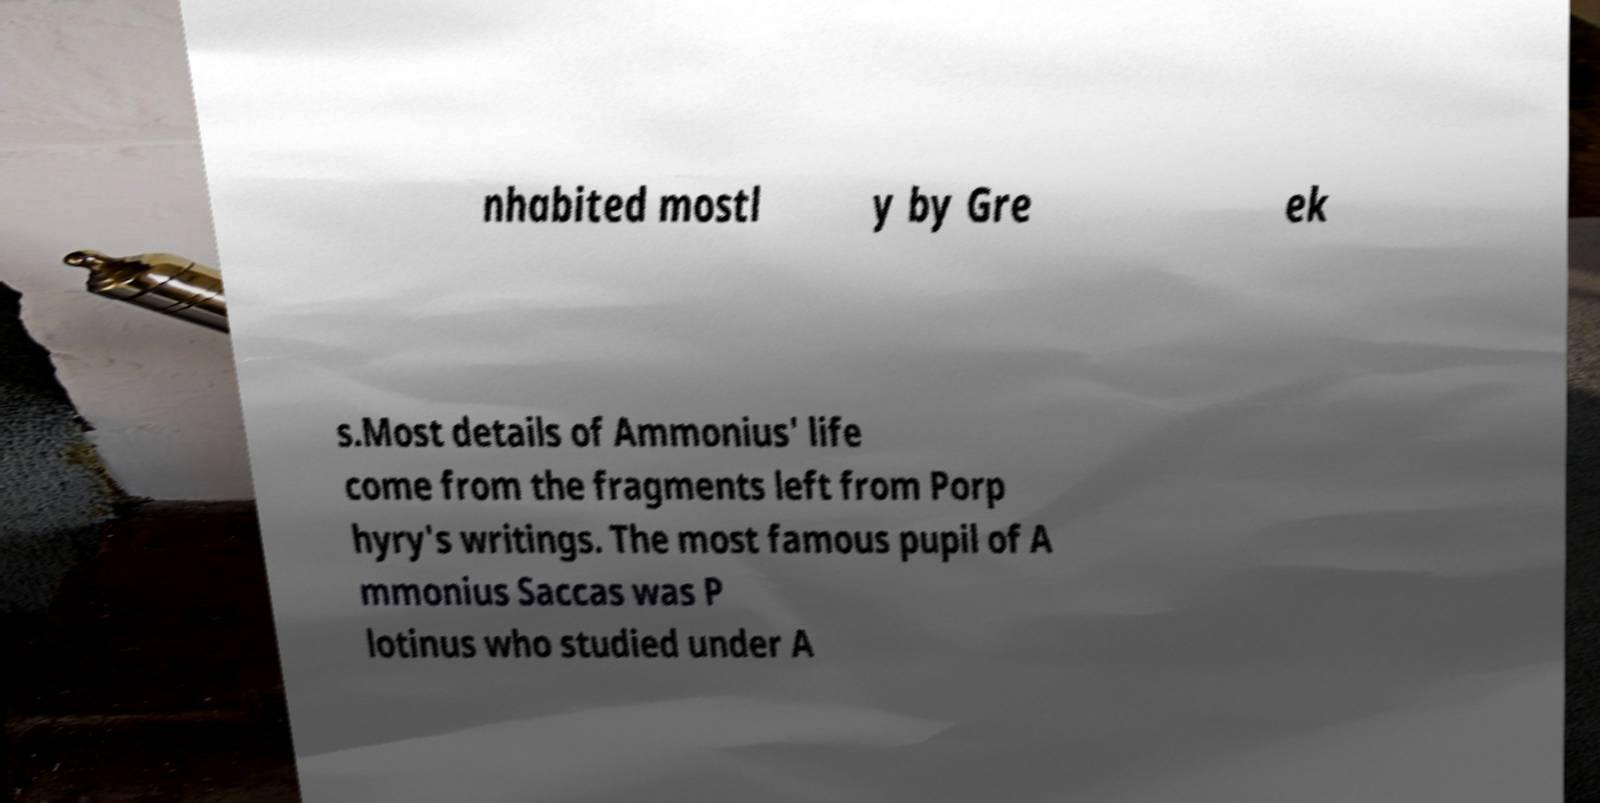I need the written content from this picture converted into text. Can you do that? nhabited mostl y by Gre ek s.Most details of Ammonius' life come from the fragments left from Porp hyry's writings. The most famous pupil of A mmonius Saccas was P lotinus who studied under A 